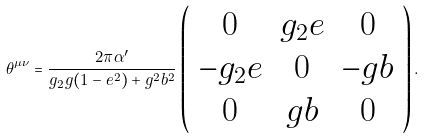<formula> <loc_0><loc_0><loc_500><loc_500>\theta ^ { \mu \nu } = \frac { 2 \pi \alpha ^ { \prime } } { g _ { 2 } g ( 1 - e ^ { 2 } ) + g ^ { 2 } b ^ { 2 } } \left ( \begin{array} { c c c } 0 & g _ { 2 } e & 0 \\ - g _ { 2 } e & 0 & - g b \\ 0 & g b & 0 \end{array} \right ) .</formula> 